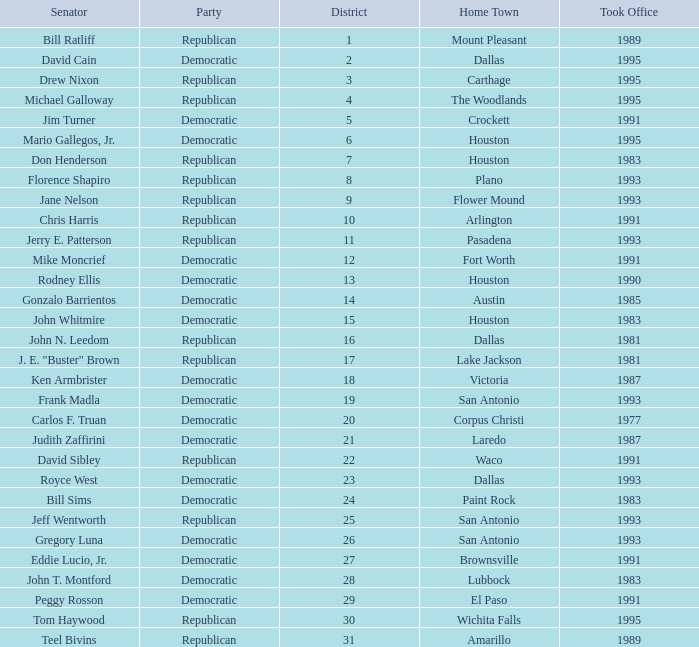What year did Senator Ken Armbrister take office? 1987.0. Parse the full table. {'header': ['Senator', 'Party', 'District', 'Home Town', 'Took Office'], 'rows': [['Bill Ratliff', 'Republican', '1', 'Mount Pleasant', '1989'], ['David Cain', 'Democratic', '2', 'Dallas', '1995'], ['Drew Nixon', 'Republican', '3', 'Carthage', '1995'], ['Michael Galloway', 'Republican', '4', 'The Woodlands', '1995'], ['Jim Turner', 'Democratic', '5', 'Crockett', '1991'], ['Mario Gallegos, Jr.', 'Democratic', '6', 'Houston', '1995'], ['Don Henderson', 'Republican', '7', 'Houston', '1983'], ['Florence Shapiro', 'Republican', '8', 'Plano', '1993'], ['Jane Nelson', 'Republican', '9', 'Flower Mound', '1993'], ['Chris Harris', 'Republican', '10', 'Arlington', '1991'], ['Jerry E. Patterson', 'Republican', '11', 'Pasadena', '1993'], ['Mike Moncrief', 'Democratic', '12', 'Fort Worth', '1991'], ['Rodney Ellis', 'Democratic', '13', 'Houston', '1990'], ['Gonzalo Barrientos', 'Democratic', '14', 'Austin', '1985'], ['John Whitmire', 'Democratic', '15', 'Houston', '1983'], ['John N. Leedom', 'Republican', '16', 'Dallas', '1981'], ['J. E. "Buster" Brown', 'Republican', '17', 'Lake Jackson', '1981'], ['Ken Armbrister', 'Democratic', '18', 'Victoria', '1987'], ['Frank Madla', 'Democratic', '19', 'San Antonio', '1993'], ['Carlos F. Truan', 'Democratic', '20', 'Corpus Christi', '1977'], ['Judith Zaffirini', 'Democratic', '21', 'Laredo', '1987'], ['David Sibley', 'Republican', '22', 'Waco', '1991'], ['Royce West', 'Democratic', '23', 'Dallas', '1993'], ['Bill Sims', 'Democratic', '24', 'Paint Rock', '1983'], ['Jeff Wentworth', 'Republican', '25', 'San Antonio', '1993'], ['Gregory Luna', 'Democratic', '26', 'San Antonio', '1993'], ['Eddie Lucio, Jr.', 'Democratic', '27', 'Brownsville', '1991'], ['John T. Montford', 'Democratic', '28', 'Lubbock', '1983'], ['Peggy Rosson', 'Democratic', '29', 'El Paso', '1991'], ['Tom Haywood', 'Republican', '30', 'Wichita Falls', '1995'], ['Teel Bivins', 'Republican', '31', 'Amarillo', '1989']]} 